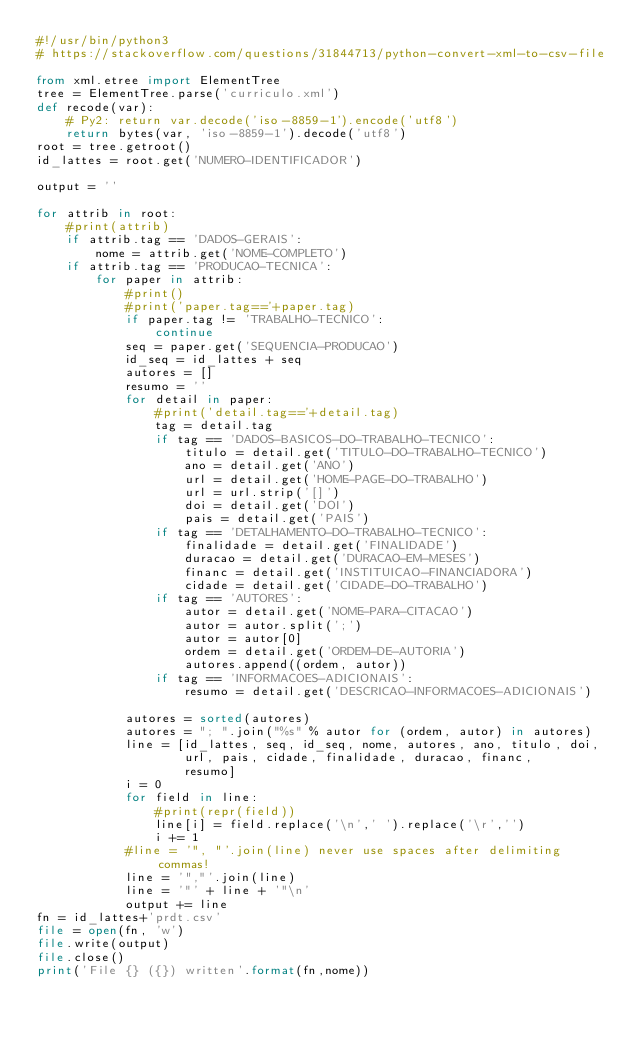<code> <loc_0><loc_0><loc_500><loc_500><_Python_>#!/usr/bin/python3
# https://stackoverflow.com/questions/31844713/python-convert-xml-to-csv-file

from xml.etree import ElementTree
tree = ElementTree.parse('curriculo.xml')
def recode(var):
    # Py2: return var.decode('iso-8859-1').encode('utf8')
    return bytes(var, 'iso-8859-1').decode('utf8')
root = tree.getroot()
id_lattes = root.get('NUMERO-IDENTIFICADOR')

output = ''

for attrib in root:
    #print(attrib)
    if attrib.tag == 'DADOS-GERAIS':
        nome = attrib.get('NOME-COMPLETO')
    if attrib.tag == 'PRODUCAO-TECNICA':
        for paper in attrib:
            #print()
            #print('paper.tag=='+paper.tag)
            if paper.tag != 'TRABALHO-TECNICO':
                continue
            seq = paper.get('SEQUENCIA-PRODUCAO')
            id_seq = id_lattes + seq
            autores = []
            resumo = ''
            for detail in paper:
                #print('detail.tag=='+detail.tag)
                tag = detail.tag
                if tag == 'DADOS-BASICOS-DO-TRABALHO-TECNICO':
                    titulo = detail.get('TITULO-DO-TRABALHO-TECNICO')
                    ano = detail.get('ANO')
                    url = detail.get('HOME-PAGE-DO-TRABALHO')
                    url = url.strip('[]')
                    doi = detail.get('DOI')
                    pais = detail.get('PAIS')
                if tag == 'DETALHAMENTO-DO-TRABALHO-TECNICO':
                    finalidade = detail.get('FINALIDADE')
                    duracao = detail.get('DURACAO-EM-MESES')
                    financ = detail.get('INSTITUICAO-FINANCIADORA')
                    cidade = detail.get('CIDADE-DO-TRABALHO')
                if tag == 'AUTORES':
                    autor = detail.get('NOME-PARA-CITACAO')
                    autor = autor.split(';')
                    autor = autor[0]
                    ordem = detail.get('ORDEM-DE-AUTORIA')
                    autores.append((ordem, autor))
                if tag == 'INFORMACOES-ADICIONAIS':
                    resumo = detail.get('DESCRICAO-INFORMACOES-ADICIONAIS')

            autores = sorted(autores)
            autores = "; ".join("%s" % autor for (ordem, autor) in autores) 
            line = [id_lattes, seq, id_seq, nome, autores, ano, titulo, doi,
                    url, pais, cidade, finalidade, duracao, financ,
                    resumo]
            i = 0
            for field in line:
                #print(repr(field))
                line[i] = field.replace('\n',' ').replace('\r','')
                i += 1
            #line = '", "'.join(line) never use spaces after delimiting commas!
            line = '","'.join(line)
            line = '"' + line + '"\n'
            output += line
fn = id_lattes+'prdt.csv'
file = open(fn, 'w')
file.write(output)
file.close()
print('File {} ({}) written'.format(fn,nome))

</code> 